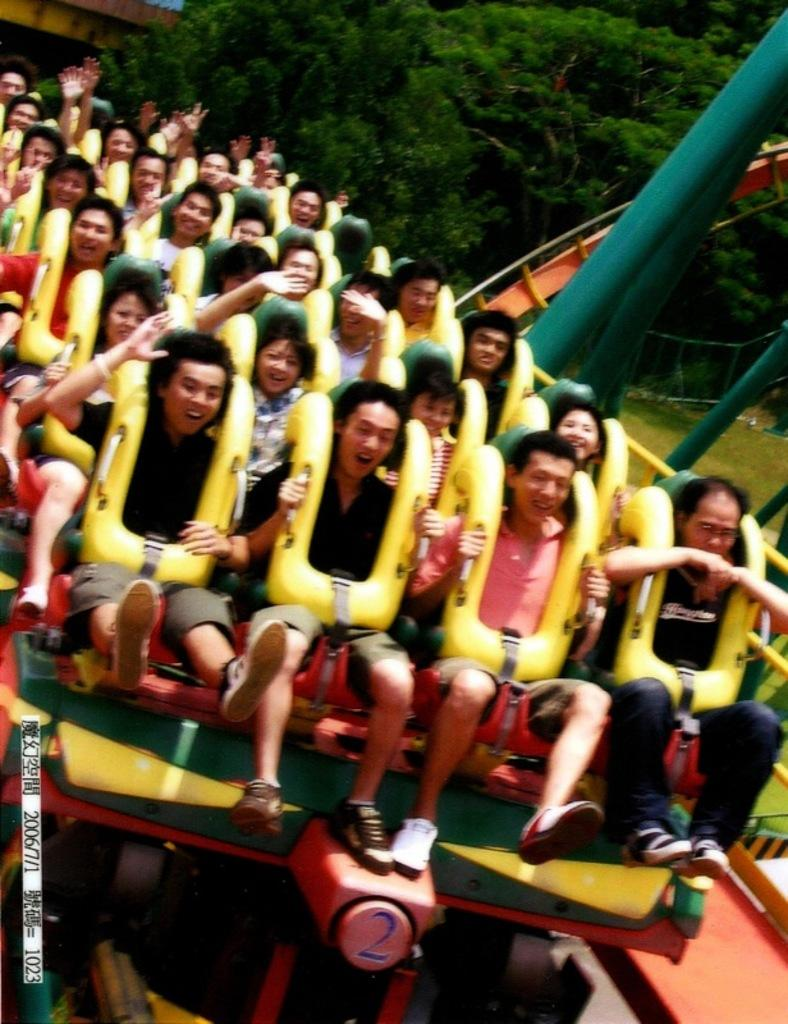What are the people in the image doing? The people are sitting on a ride in the image. What can be seen supporting the ride? There are rods visible in the image. What type of natural environment is visible in the image? There is grass present in the image. What is visible in the background of the image? There are trees in the background of the image. What type of van is parked near the ride in the image? There is no van present in the image. What type of competition are the people participating in on the ride? There is no competition present in the image; the people are simply sitting on the ride. 